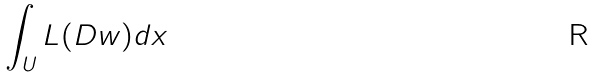<formula> <loc_0><loc_0><loc_500><loc_500>\int _ { U } L ( D w ) d x</formula> 